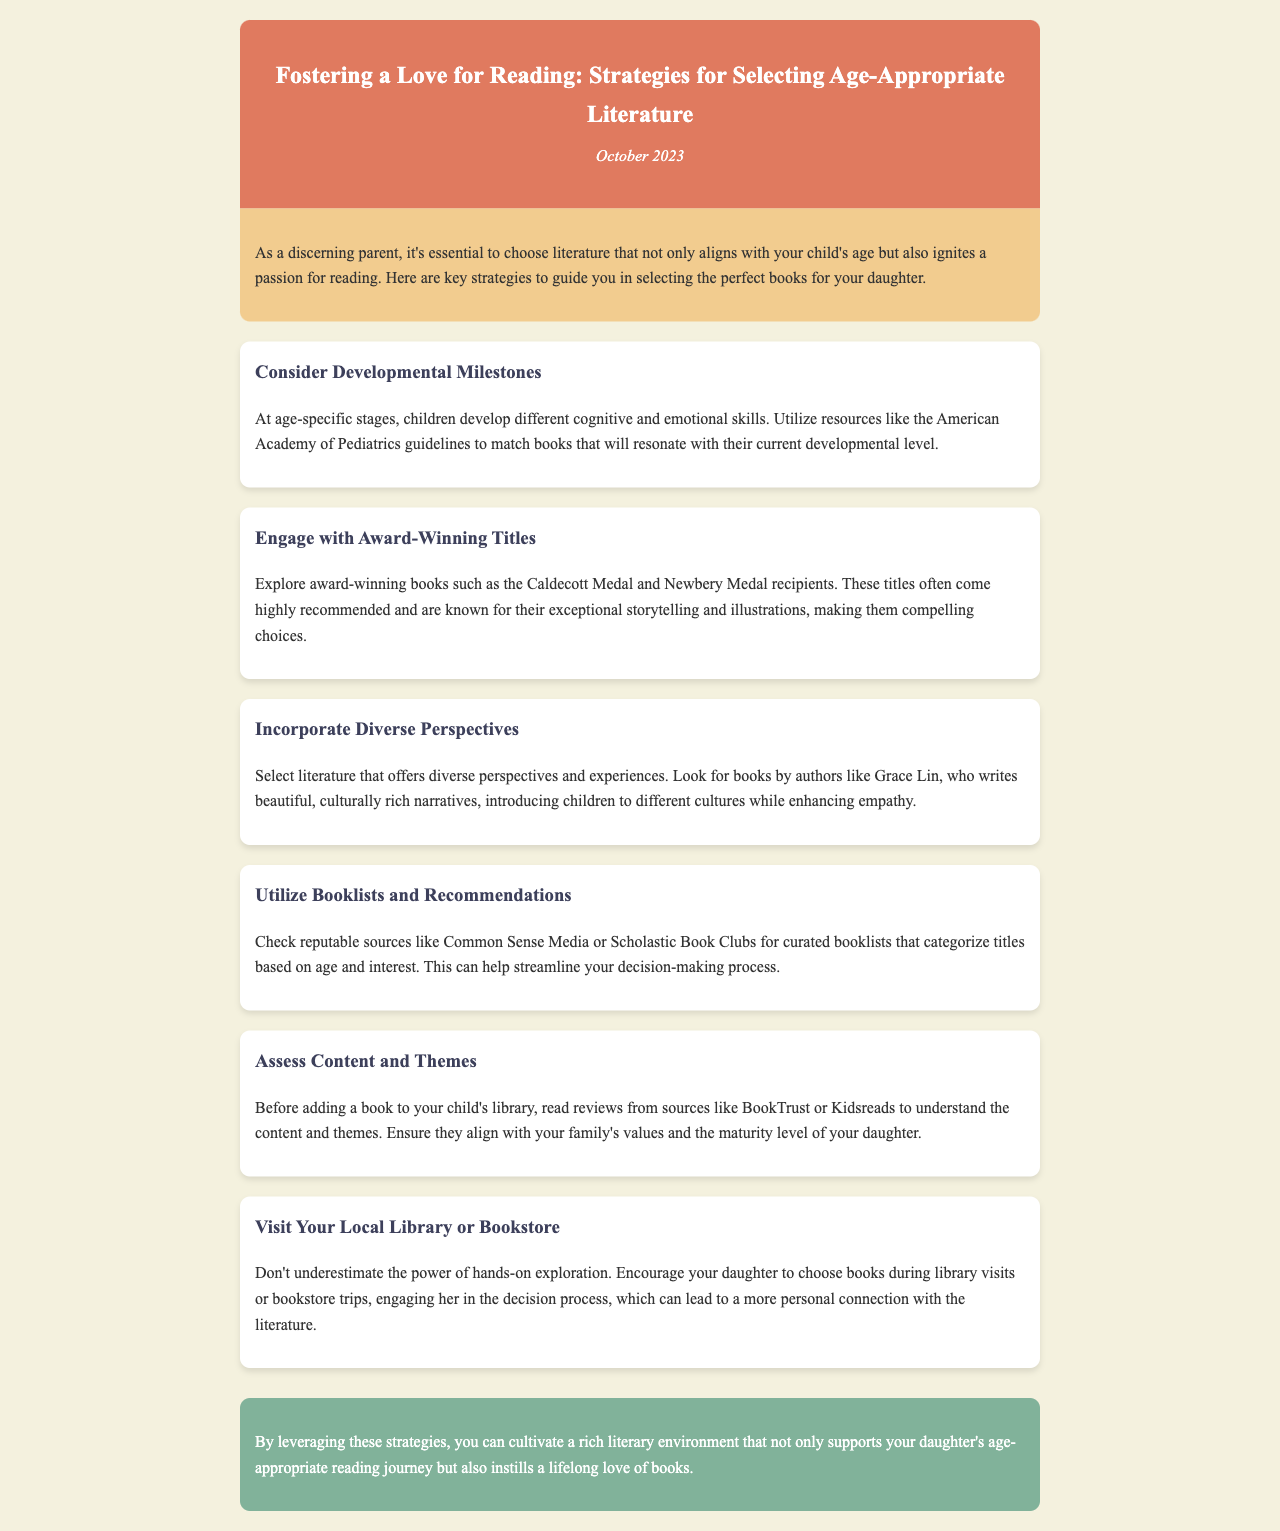what is the title of the newsletter? The title of the newsletter is prominently displayed in the header section.
Answer: Fostering a Love for Reading: Strategies for Selecting Age-Appropriate Literature what is the date of the newsletter? The date is found in the designated section under the title.
Answer: October 2023 what is one strategy for selecting literature mentioned in the document? The document outlines several strategies for selecting literature.
Answer: Consider Developmental Milestones who can provide guidelines for matching books to developmental levels? The American Academy of Pediatrics provides guidelines in the document.
Answer: American Academy of Pediatrics what type of books does the document recommend exploring? The document highlights specific categories of books worth exploring.
Answer: Award-winning books how can parents facilitate their child's book selection? The document suggests a hands-on approach for involving children.
Answer: Visit Your Local Library or Bookstore what is a recommended source for curated booklists? The document mentions reliable sources for booklists.
Answer: Common Sense Media what is one author mentioned who writes culturally rich narratives? The document specifically names an author in the context of diverse literature.
Answer: Grace Lin what is the purpose of assessing content and themes before book selection? The document explains the reason for evaluating literature before inclusion.
Answer: Align with family's values 